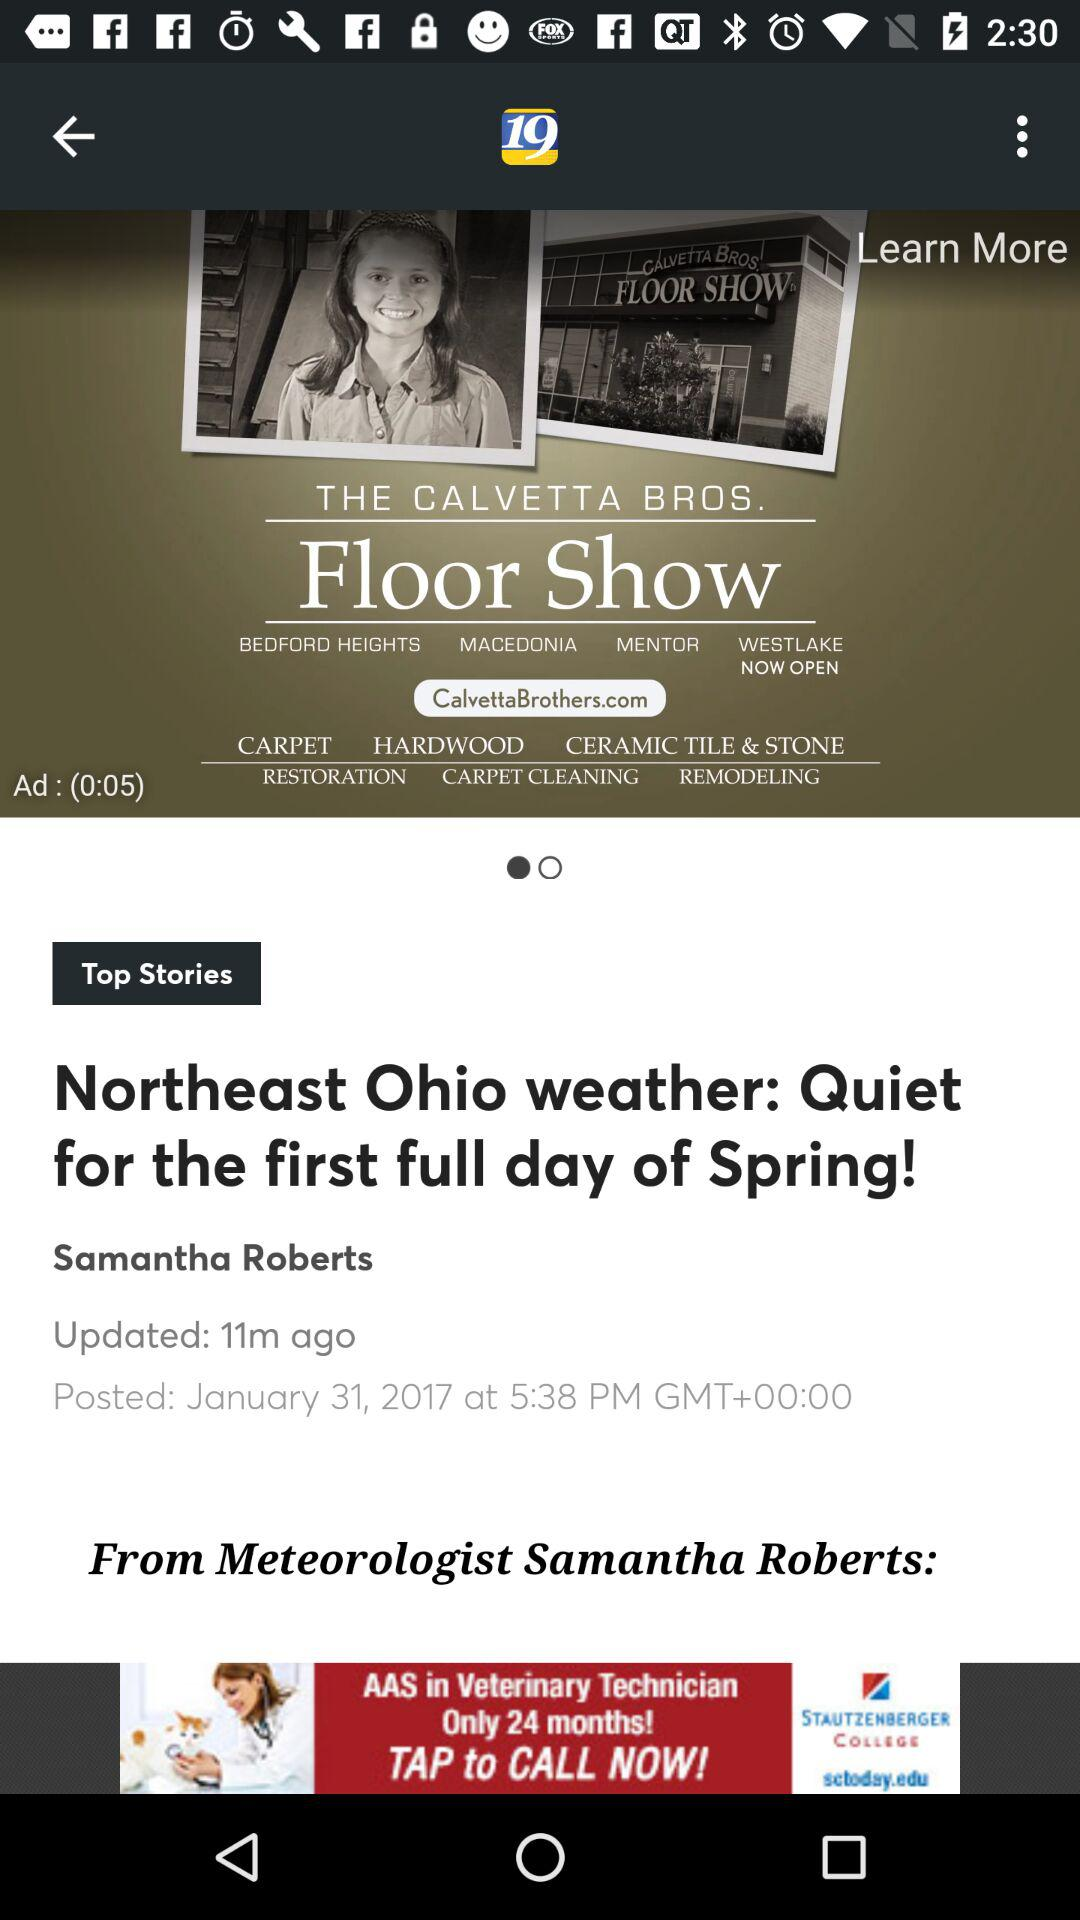When was the article posted? The article was posted on January 31, 2017 at 5:38 PM in Greenwich Mean Time. 